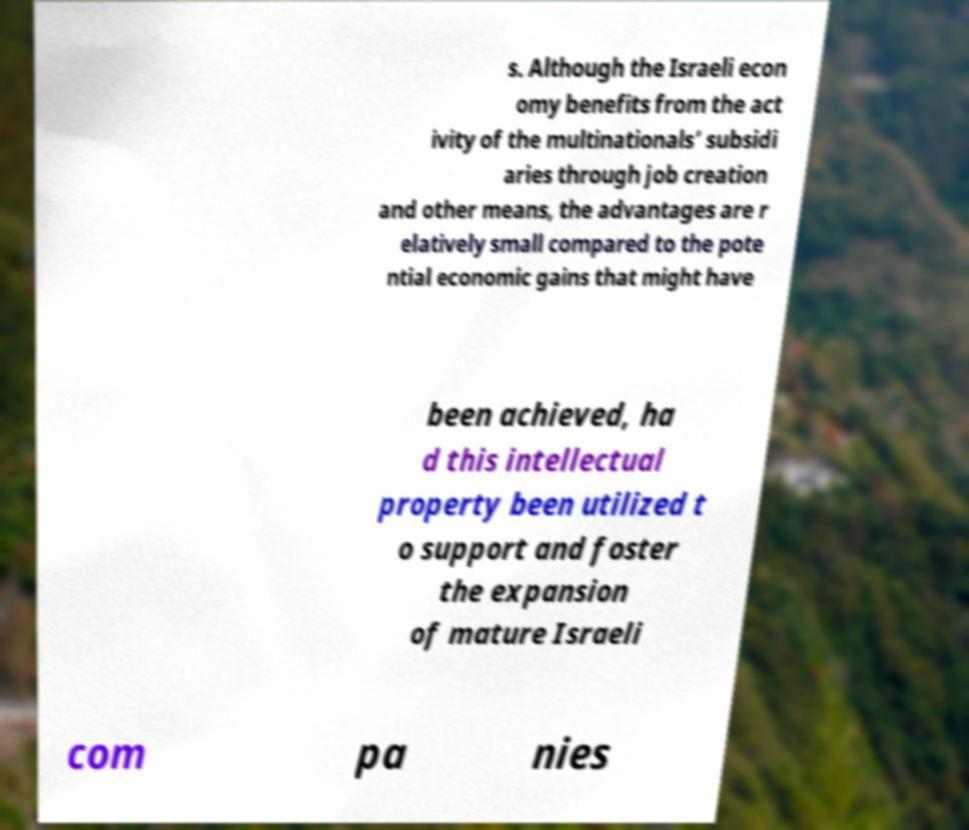For documentation purposes, I need the text within this image transcribed. Could you provide that? s. Although the Israeli econ omy benefits from the act ivity of the multinationals’ subsidi aries through job creation and other means, the advantages are r elatively small compared to the pote ntial economic gains that might have been achieved, ha d this intellectual property been utilized t o support and foster the expansion of mature Israeli com pa nies 